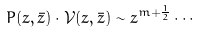<formula> <loc_0><loc_0><loc_500><loc_500>P ( z , \bar { z } ) \cdot \mathcal { V } ( z , \bar { z } ) \sim z ^ { m + \frac { 1 } { 2 } } \cdots</formula> 